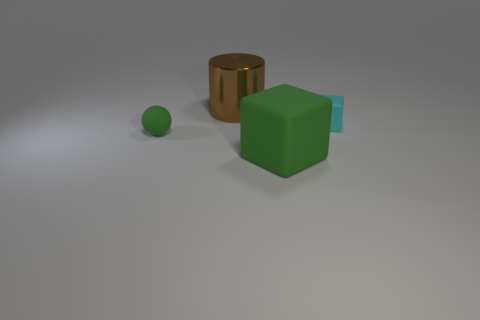Is there any other thing that has the same shape as the tiny green matte thing?
Make the answer very short. No. How many things have the same color as the big rubber block?
Offer a terse response. 1. Is the matte sphere the same color as the large matte block?
Your answer should be compact. Yes. There is a matte object that is on the left side of the cylinder; is it the same size as the matte block in front of the tiny cyan rubber cube?
Keep it short and to the point. No. What shape is the big green thing?
Provide a succinct answer. Cube. There is a ball that is the same color as the big cube; what size is it?
Offer a terse response. Small. The tiny block that is the same material as the small green sphere is what color?
Keep it short and to the point. Cyan. Does the tiny cube have the same material as the large thing left of the big green matte object?
Your answer should be very brief. No. The tiny matte cube has what color?
Your answer should be compact. Cyan. The cyan block that is the same material as the tiny green ball is what size?
Your answer should be compact. Small. 